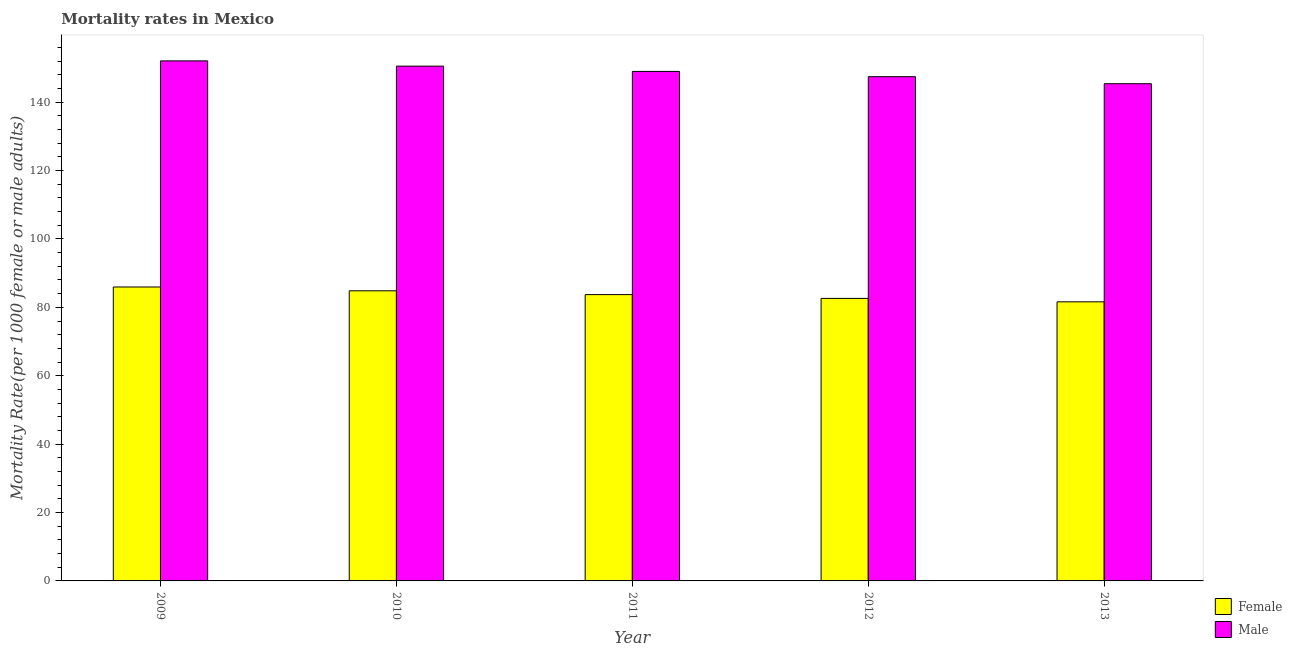How many different coloured bars are there?
Offer a terse response. 2. How many groups of bars are there?
Make the answer very short. 5. How many bars are there on the 4th tick from the left?
Provide a short and direct response. 2. How many bars are there on the 2nd tick from the right?
Ensure brevity in your answer.  2. What is the female mortality rate in 2013?
Offer a terse response. 81.61. Across all years, what is the maximum male mortality rate?
Ensure brevity in your answer.  152.06. Across all years, what is the minimum male mortality rate?
Offer a very short reply. 145.39. In which year was the male mortality rate minimum?
Provide a short and direct response. 2013. What is the total male mortality rate in the graph?
Offer a very short reply. 744.4. What is the difference between the female mortality rate in 2010 and that in 2013?
Your answer should be very brief. 3.23. What is the difference between the male mortality rate in 2012 and the female mortality rate in 2009?
Ensure brevity in your answer.  -4.62. What is the average male mortality rate per year?
Your response must be concise. 148.88. In how many years, is the female mortality rate greater than 120?
Provide a short and direct response. 0. What is the ratio of the female mortality rate in 2011 to that in 2013?
Your response must be concise. 1.03. Is the difference between the male mortality rate in 2010 and 2011 greater than the difference between the female mortality rate in 2010 and 2011?
Offer a terse response. No. What is the difference between the highest and the second highest female mortality rate?
Provide a succinct answer. 1.11. What is the difference between the highest and the lowest male mortality rate?
Make the answer very short. 6.68. In how many years, is the male mortality rate greater than the average male mortality rate taken over all years?
Give a very brief answer. 3. What does the 2nd bar from the left in 2012 represents?
Give a very brief answer. Male. Are all the bars in the graph horizontal?
Offer a terse response. No. What is the difference between two consecutive major ticks on the Y-axis?
Keep it short and to the point. 20. Does the graph contain grids?
Keep it short and to the point. No. How many legend labels are there?
Ensure brevity in your answer.  2. What is the title of the graph?
Keep it short and to the point. Mortality rates in Mexico. What is the label or title of the Y-axis?
Offer a very short reply. Mortality Rate(per 1000 female or male adults). What is the Mortality Rate(per 1000 female or male adults) of Female in 2009?
Your response must be concise. 85.95. What is the Mortality Rate(per 1000 female or male adults) of Male in 2009?
Your answer should be very brief. 152.06. What is the Mortality Rate(per 1000 female or male adults) in Female in 2010?
Offer a very short reply. 84.83. What is the Mortality Rate(per 1000 female or male adults) of Male in 2010?
Your response must be concise. 150.52. What is the Mortality Rate(per 1000 female or male adults) in Female in 2011?
Your answer should be compact. 83.72. What is the Mortality Rate(per 1000 female or male adults) of Male in 2011?
Offer a very short reply. 148.98. What is the Mortality Rate(per 1000 female or male adults) in Female in 2012?
Your response must be concise. 82.61. What is the Mortality Rate(per 1000 female or male adults) of Male in 2012?
Your answer should be very brief. 147.44. What is the Mortality Rate(per 1000 female or male adults) in Female in 2013?
Make the answer very short. 81.61. What is the Mortality Rate(per 1000 female or male adults) of Male in 2013?
Offer a terse response. 145.39. Across all years, what is the maximum Mortality Rate(per 1000 female or male adults) in Female?
Keep it short and to the point. 85.95. Across all years, what is the maximum Mortality Rate(per 1000 female or male adults) in Male?
Your answer should be compact. 152.06. Across all years, what is the minimum Mortality Rate(per 1000 female or male adults) of Female?
Give a very brief answer. 81.61. Across all years, what is the minimum Mortality Rate(per 1000 female or male adults) in Male?
Offer a very short reply. 145.39. What is the total Mortality Rate(per 1000 female or male adults) of Female in the graph?
Give a very brief answer. 418.72. What is the total Mortality Rate(per 1000 female or male adults) in Male in the graph?
Keep it short and to the point. 744.4. What is the difference between the Mortality Rate(per 1000 female or male adults) of Female in 2009 and that in 2010?
Your answer should be very brief. 1.11. What is the difference between the Mortality Rate(per 1000 female or male adults) of Male in 2009 and that in 2010?
Keep it short and to the point. 1.54. What is the difference between the Mortality Rate(per 1000 female or male adults) of Female in 2009 and that in 2011?
Ensure brevity in your answer.  2.22. What is the difference between the Mortality Rate(per 1000 female or male adults) of Male in 2009 and that in 2011?
Make the answer very short. 3.08. What is the difference between the Mortality Rate(per 1000 female or male adults) of Female in 2009 and that in 2012?
Provide a short and direct response. 3.34. What is the difference between the Mortality Rate(per 1000 female or male adults) of Male in 2009 and that in 2012?
Your response must be concise. 4.62. What is the difference between the Mortality Rate(per 1000 female or male adults) in Female in 2009 and that in 2013?
Keep it short and to the point. 4.34. What is the difference between the Mortality Rate(per 1000 female or male adults) in Male in 2009 and that in 2013?
Your response must be concise. 6.68. What is the difference between the Mortality Rate(per 1000 female or male adults) in Female in 2010 and that in 2011?
Ensure brevity in your answer.  1.11. What is the difference between the Mortality Rate(per 1000 female or male adults) in Male in 2010 and that in 2011?
Make the answer very short. 1.54. What is the difference between the Mortality Rate(per 1000 female or male adults) in Female in 2010 and that in 2012?
Give a very brief answer. 2.22. What is the difference between the Mortality Rate(per 1000 female or male adults) of Male in 2010 and that in 2012?
Ensure brevity in your answer.  3.08. What is the difference between the Mortality Rate(per 1000 female or male adults) of Female in 2010 and that in 2013?
Your answer should be compact. 3.23. What is the difference between the Mortality Rate(per 1000 female or male adults) in Male in 2010 and that in 2013?
Your response must be concise. 5.14. What is the difference between the Mortality Rate(per 1000 female or male adults) in Female in 2011 and that in 2012?
Offer a terse response. 1.11. What is the difference between the Mortality Rate(per 1000 female or male adults) in Male in 2011 and that in 2012?
Ensure brevity in your answer.  1.54. What is the difference between the Mortality Rate(per 1000 female or male adults) of Female in 2011 and that in 2013?
Your answer should be compact. 2.11. What is the difference between the Mortality Rate(per 1000 female or male adults) in Male in 2011 and that in 2013?
Provide a succinct answer. 3.6. What is the difference between the Mortality Rate(per 1000 female or male adults) in Male in 2012 and that in 2013?
Keep it short and to the point. 2.06. What is the difference between the Mortality Rate(per 1000 female or male adults) of Female in 2009 and the Mortality Rate(per 1000 female or male adults) of Male in 2010?
Your response must be concise. -64.58. What is the difference between the Mortality Rate(per 1000 female or male adults) of Female in 2009 and the Mortality Rate(per 1000 female or male adults) of Male in 2011?
Ensure brevity in your answer.  -63.04. What is the difference between the Mortality Rate(per 1000 female or male adults) of Female in 2009 and the Mortality Rate(per 1000 female or male adults) of Male in 2012?
Your answer should be compact. -61.5. What is the difference between the Mortality Rate(per 1000 female or male adults) in Female in 2009 and the Mortality Rate(per 1000 female or male adults) in Male in 2013?
Keep it short and to the point. -59.44. What is the difference between the Mortality Rate(per 1000 female or male adults) of Female in 2010 and the Mortality Rate(per 1000 female or male adults) of Male in 2011?
Make the answer very short. -64.15. What is the difference between the Mortality Rate(per 1000 female or male adults) of Female in 2010 and the Mortality Rate(per 1000 female or male adults) of Male in 2012?
Provide a short and direct response. -62.61. What is the difference between the Mortality Rate(per 1000 female or male adults) of Female in 2010 and the Mortality Rate(per 1000 female or male adults) of Male in 2013?
Ensure brevity in your answer.  -60.55. What is the difference between the Mortality Rate(per 1000 female or male adults) in Female in 2011 and the Mortality Rate(per 1000 female or male adults) in Male in 2012?
Keep it short and to the point. -63.72. What is the difference between the Mortality Rate(per 1000 female or male adults) of Female in 2011 and the Mortality Rate(per 1000 female or male adults) of Male in 2013?
Offer a very short reply. -61.66. What is the difference between the Mortality Rate(per 1000 female or male adults) of Female in 2012 and the Mortality Rate(per 1000 female or male adults) of Male in 2013?
Provide a succinct answer. -62.78. What is the average Mortality Rate(per 1000 female or male adults) of Female per year?
Give a very brief answer. 83.74. What is the average Mortality Rate(per 1000 female or male adults) of Male per year?
Give a very brief answer. 148.88. In the year 2009, what is the difference between the Mortality Rate(per 1000 female or male adults) in Female and Mortality Rate(per 1000 female or male adults) in Male?
Your answer should be very brief. -66.12. In the year 2010, what is the difference between the Mortality Rate(per 1000 female or male adults) in Female and Mortality Rate(per 1000 female or male adults) in Male?
Offer a very short reply. -65.69. In the year 2011, what is the difference between the Mortality Rate(per 1000 female or male adults) of Female and Mortality Rate(per 1000 female or male adults) of Male?
Provide a short and direct response. -65.26. In the year 2012, what is the difference between the Mortality Rate(per 1000 female or male adults) of Female and Mortality Rate(per 1000 female or male adults) of Male?
Make the answer very short. -64.83. In the year 2013, what is the difference between the Mortality Rate(per 1000 female or male adults) of Female and Mortality Rate(per 1000 female or male adults) of Male?
Offer a very short reply. -63.78. What is the ratio of the Mortality Rate(per 1000 female or male adults) in Female in 2009 to that in 2010?
Make the answer very short. 1.01. What is the ratio of the Mortality Rate(per 1000 female or male adults) of Male in 2009 to that in 2010?
Provide a short and direct response. 1.01. What is the ratio of the Mortality Rate(per 1000 female or male adults) of Female in 2009 to that in 2011?
Give a very brief answer. 1.03. What is the ratio of the Mortality Rate(per 1000 female or male adults) of Male in 2009 to that in 2011?
Give a very brief answer. 1.02. What is the ratio of the Mortality Rate(per 1000 female or male adults) in Female in 2009 to that in 2012?
Your response must be concise. 1.04. What is the ratio of the Mortality Rate(per 1000 female or male adults) in Male in 2009 to that in 2012?
Your response must be concise. 1.03. What is the ratio of the Mortality Rate(per 1000 female or male adults) of Female in 2009 to that in 2013?
Offer a very short reply. 1.05. What is the ratio of the Mortality Rate(per 1000 female or male adults) of Male in 2009 to that in 2013?
Offer a terse response. 1.05. What is the ratio of the Mortality Rate(per 1000 female or male adults) of Female in 2010 to that in 2011?
Provide a succinct answer. 1.01. What is the ratio of the Mortality Rate(per 1000 female or male adults) in Male in 2010 to that in 2011?
Ensure brevity in your answer.  1.01. What is the ratio of the Mortality Rate(per 1000 female or male adults) of Female in 2010 to that in 2012?
Your answer should be very brief. 1.03. What is the ratio of the Mortality Rate(per 1000 female or male adults) of Male in 2010 to that in 2012?
Offer a terse response. 1.02. What is the ratio of the Mortality Rate(per 1000 female or male adults) in Female in 2010 to that in 2013?
Your response must be concise. 1.04. What is the ratio of the Mortality Rate(per 1000 female or male adults) in Male in 2010 to that in 2013?
Offer a terse response. 1.04. What is the ratio of the Mortality Rate(per 1000 female or male adults) in Female in 2011 to that in 2012?
Give a very brief answer. 1.01. What is the ratio of the Mortality Rate(per 1000 female or male adults) in Male in 2011 to that in 2012?
Provide a succinct answer. 1.01. What is the ratio of the Mortality Rate(per 1000 female or male adults) of Female in 2011 to that in 2013?
Make the answer very short. 1.03. What is the ratio of the Mortality Rate(per 1000 female or male adults) of Male in 2011 to that in 2013?
Provide a short and direct response. 1.02. What is the ratio of the Mortality Rate(per 1000 female or male adults) of Female in 2012 to that in 2013?
Make the answer very short. 1.01. What is the ratio of the Mortality Rate(per 1000 female or male adults) in Male in 2012 to that in 2013?
Your answer should be compact. 1.01. What is the difference between the highest and the second highest Mortality Rate(per 1000 female or male adults) in Female?
Give a very brief answer. 1.11. What is the difference between the highest and the second highest Mortality Rate(per 1000 female or male adults) of Male?
Give a very brief answer. 1.54. What is the difference between the highest and the lowest Mortality Rate(per 1000 female or male adults) in Female?
Ensure brevity in your answer.  4.34. What is the difference between the highest and the lowest Mortality Rate(per 1000 female or male adults) of Male?
Make the answer very short. 6.68. 